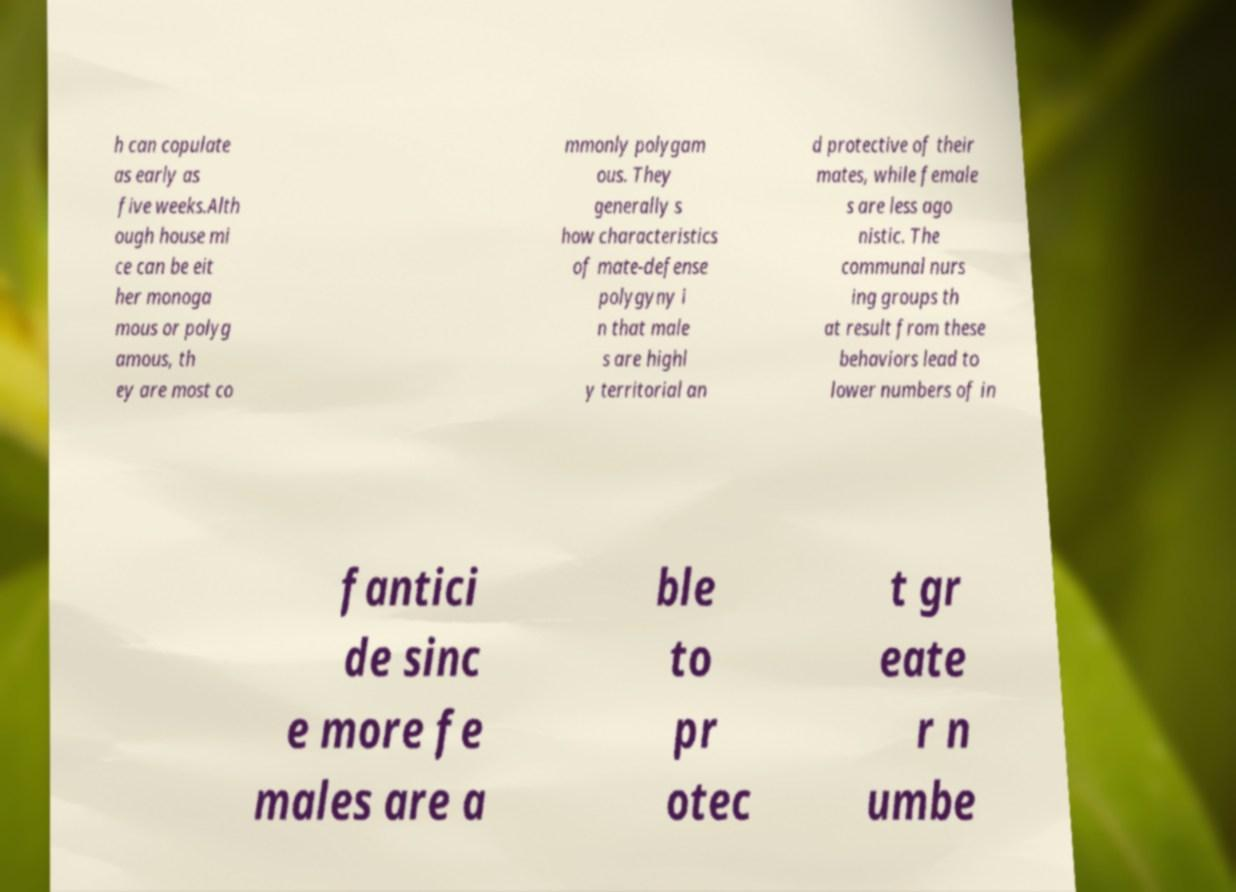Can you accurately transcribe the text from the provided image for me? h can copulate as early as five weeks.Alth ough house mi ce can be eit her monoga mous or polyg amous, th ey are most co mmonly polygam ous. They generally s how characteristics of mate-defense polygyny i n that male s are highl y territorial an d protective of their mates, while female s are less ago nistic. The communal nurs ing groups th at result from these behaviors lead to lower numbers of in fantici de sinc e more fe males are a ble to pr otec t gr eate r n umbe 